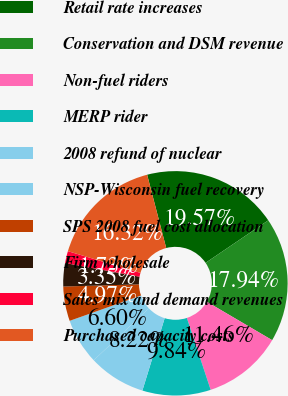<chart> <loc_0><loc_0><loc_500><loc_500><pie_chart><fcel>Retail rate increases<fcel>Conservation and DSM revenue<fcel>Non-fuel riders<fcel>MERP rider<fcel>2008 refund of nuclear<fcel>NSP-Wisconsin fuel recovery<fcel>SPS 2008 fuel cost allocation<fcel>Firm wholesale<fcel>Sales mix and demand revenues<fcel>Purchased capacity costs<nl><fcel>19.57%<fcel>17.94%<fcel>11.46%<fcel>9.84%<fcel>8.22%<fcel>6.6%<fcel>4.97%<fcel>3.35%<fcel>1.73%<fcel>16.32%<nl></chart> 